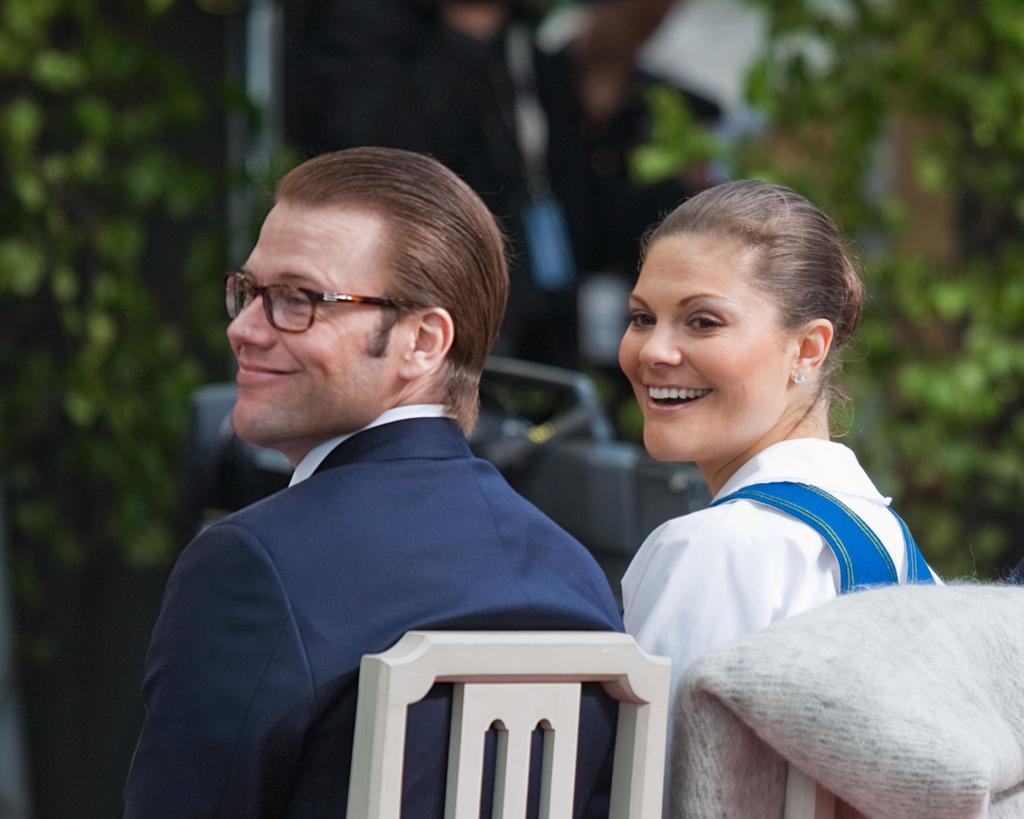Please provide a concise description of this image. In this picture we can see one person, woman sitting on the chairs, around we can see some trees. 